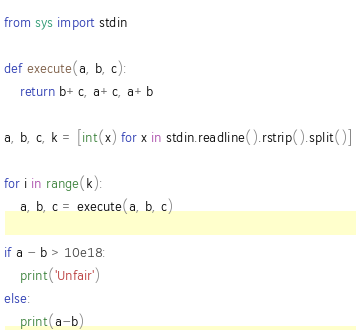<code> <loc_0><loc_0><loc_500><loc_500><_Python_>from sys import stdin

def execute(a, b, c):
    return b+c, a+c, a+b

a, b, c, k = [int(x) for x in stdin.readline().rstrip().split()]

for i in range(k):
    a, b, c = execute(a, b, c)

if a - b > 10e18:
    print('Unfair')
else:
    print(a-b)
</code> 